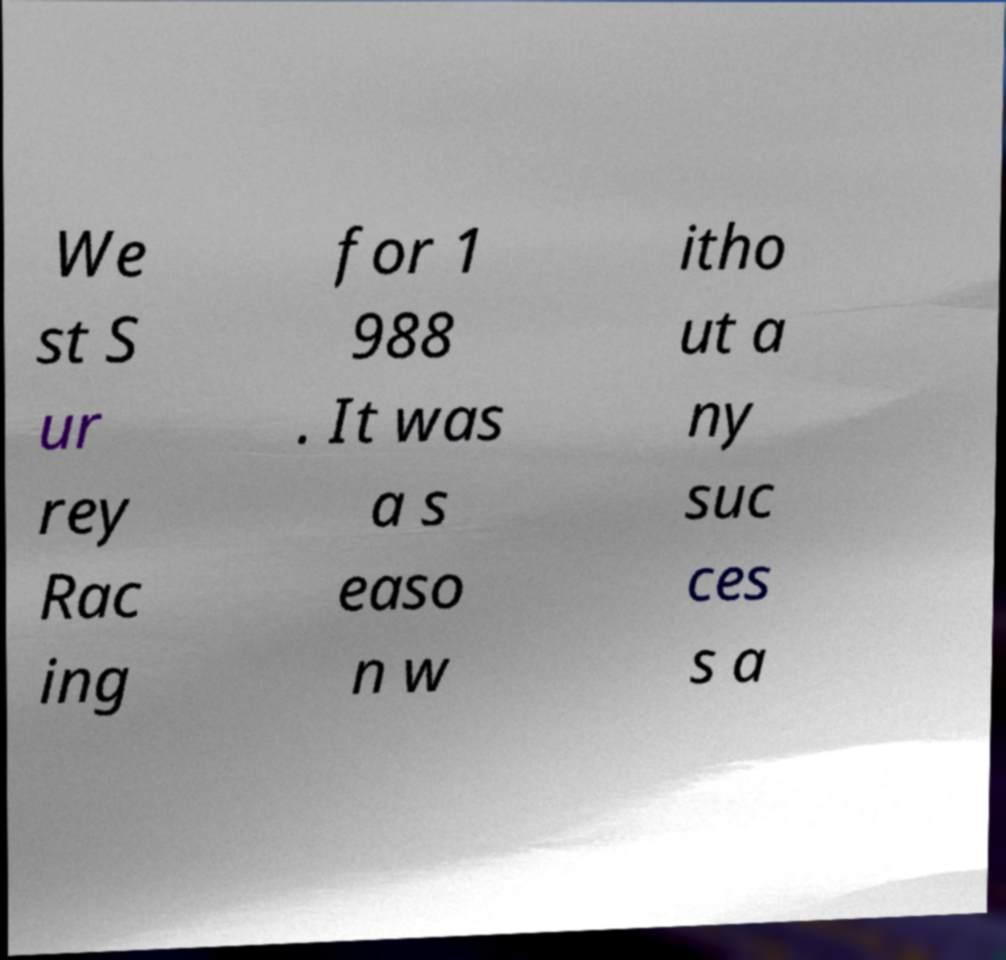Can you read and provide the text displayed in the image?This photo seems to have some interesting text. Can you extract and type it out for me? We st S ur rey Rac ing for 1 988 . It was a s easo n w itho ut a ny suc ces s a 